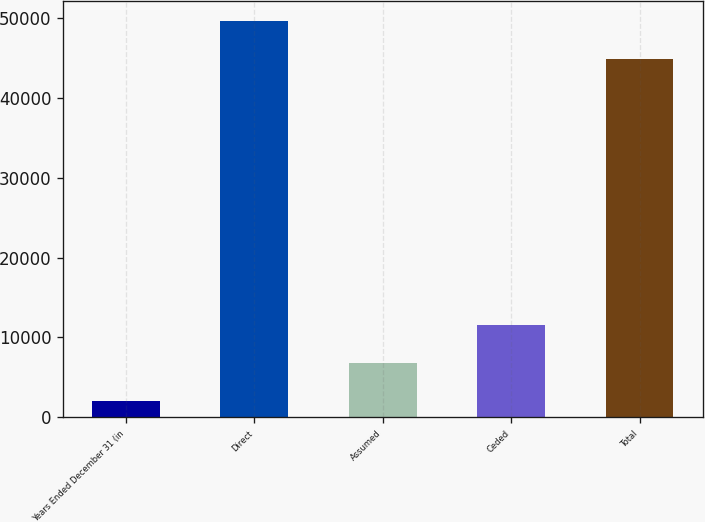Convert chart to OTSL. <chart><loc_0><loc_0><loc_500><loc_500><bar_chart><fcel>Years Ended December 31 (in<fcel>Direct<fcel>Assumed<fcel>Ceded<fcel>Total<nl><fcel>2006<fcel>49626.3<fcel>6766.3<fcel>11526.6<fcel>44866<nl></chart> 